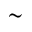<formula> <loc_0><loc_0><loc_500><loc_500>\sim</formula> 